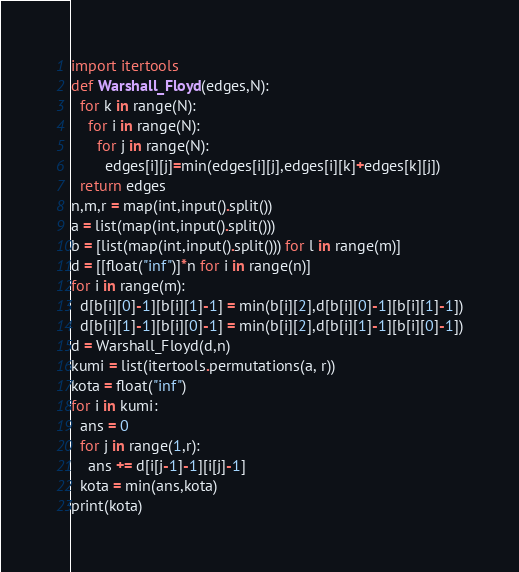<code> <loc_0><loc_0><loc_500><loc_500><_Python_>import itertools
def Warshall_Floyd(edges,N):
  for k in range(N):
    for i in range(N):
      for j in range(N):
        edges[i][j]=min(edges[i][j],edges[i][k]+edges[k][j])
  return edges
n,m,r = map(int,input().split())
a = list(map(int,input().split()))
b = [list(map(int,input().split())) for l in range(m)]
d = [[float("inf")]*n for i in range(n)]
for i in range(m):
  d[b[i][0]-1][b[i][1]-1] = min(b[i][2],d[b[i][0]-1][b[i][1]-1])
  d[b[i][1]-1][b[i][0]-1] = min(b[i][2],d[b[i][1]-1][b[i][0]-1])
d = Warshall_Floyd(d,n)
kumi = list(itertools.permutations(a, r))
kota = float("inf")
for i in kumi:
  ans = 0
  for j in range(1,r):
    ans += d[i[j-1]-1][i[j]-1]
  kota = min(ans,kota)
print(kota)</code> 